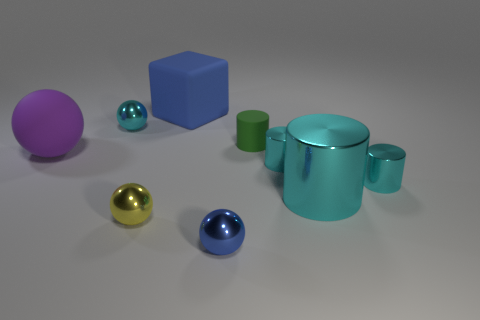Is the number of tiny cyan metallic cylinders that are behind the tiny cyan metal sphere the same as the number of metallic objects in front of the big cyan metal object?
Give a very brief answer. No. What color is the other rubber object that is the same shape as the tiny blue thing?
Give a very brief answer. Purple. Is there any other thing that has the same shape as the large blue thing?
Keep it short and to the point. No. Is the color of the small sphere behind the purple matte sphere the same as the big cylinder?
Ensure brevity in your answer.  Yes. The blue shiny object that is the same shape as the purple matte object is what size?
Give a very brief answer. Small. What number of cyan spheres are made of the same material as the large blue object?
Make the answer very short. 0. Are there any small cyan shiny objects that are behind the matte cylinder that is left of the large thing to the right of the big matte block?
Offer a very short reply. Yes. The large blue rubber object is what shape?
Offer a terse response. Cube. Are the blue thing in front of the big cyan object and the cyan object on the left side of the green rubber object made of the same material?
Keep it short and to the point. Yes. What number of tiny spheres are the same color as the cube?
Your answer should be compact. 1. 